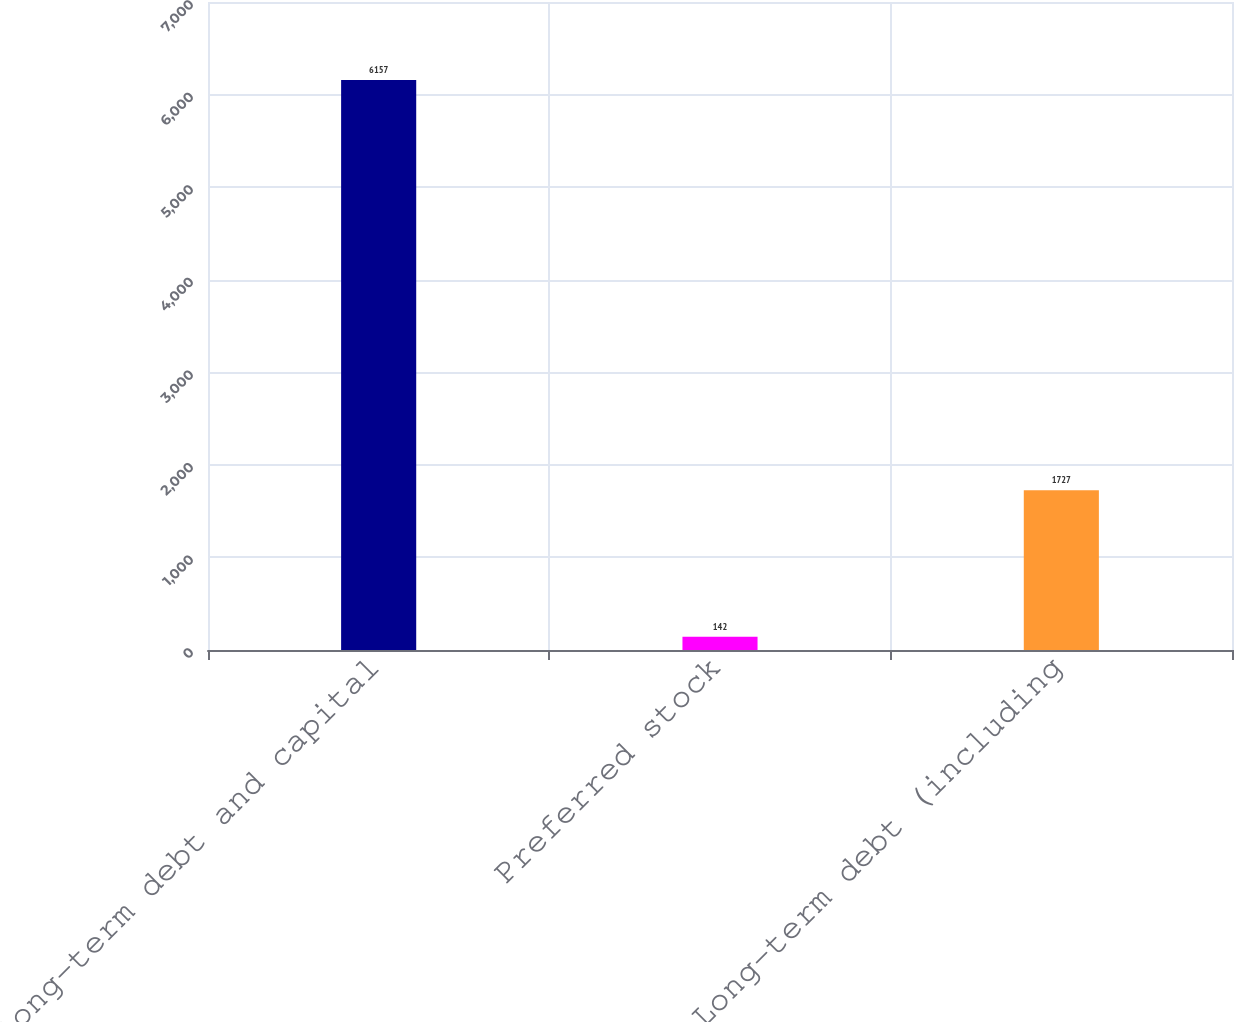Convert chart. <chart><loc_0><loc_0><loc_500><loc_500><bar_chart><fcel>Long-term debt and capital<fcel>Preferred stock<fcel>Long-term debt (including<nl><fcel>6157<fcel>142<fcel>1727<nl></chart> 